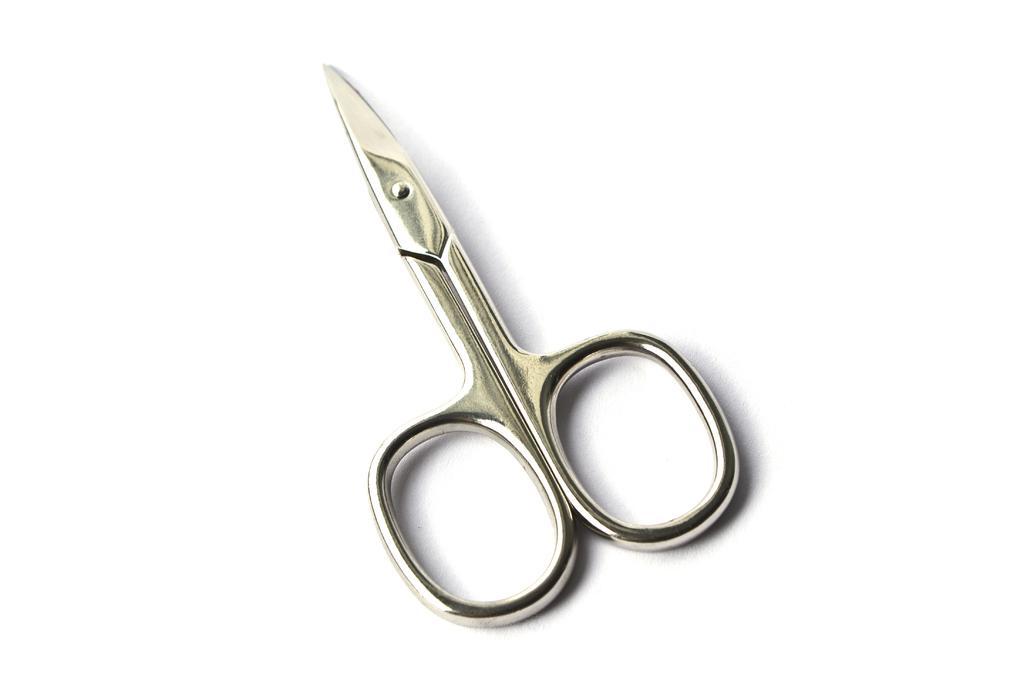Could you give a brief overview of what you see in this image? In the center of this picture we can see a scissors is placed on a surface of a white color object. 